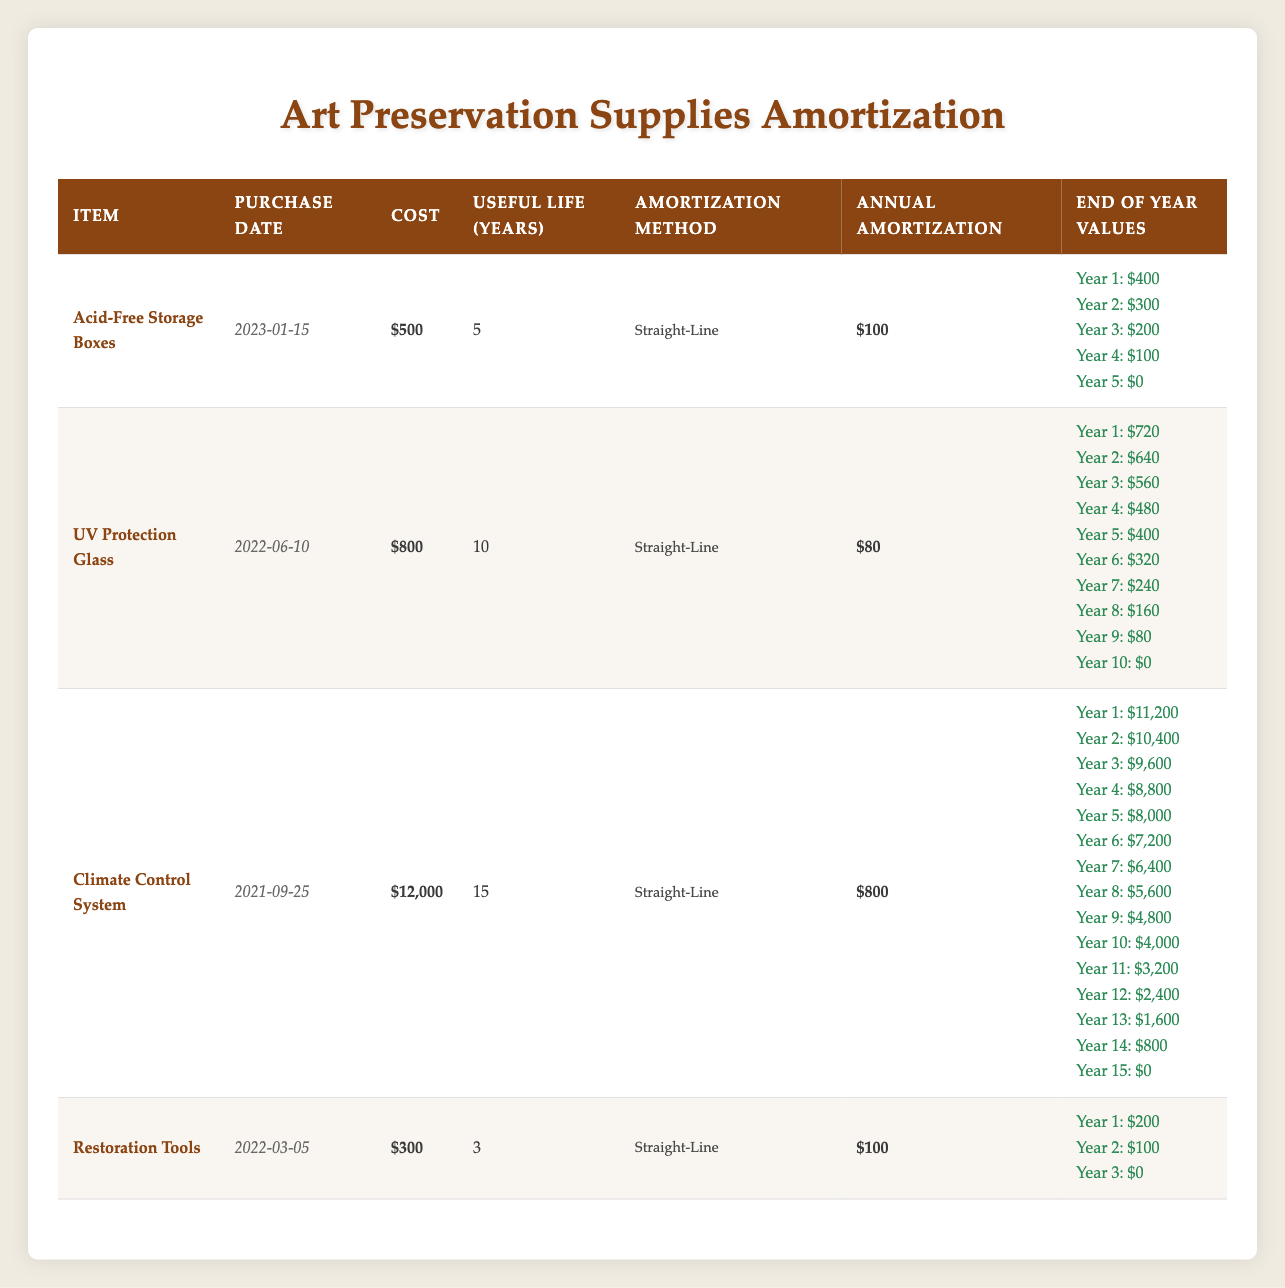What is the annual amortization for the Acid-Free Storage Boxes? The table shows the acid-free storage boxes have an annual amortization of $100 under the "Annual Amortization" column.
Answer: 100 How much is the end-of-year value for the UV Protection Glass at the end of year 5? Looking at the table, the end-of-year value for the UV Protection Glass at year 5 is listed as $400.
Answer: 400 Is the useful life for Restoration Tools greater than 3 years? The table shows that the useful life of the Restoration Tools is exactly 3 years, so the statement is false.
Answer: No What is the total cost of the Climate Control System? The table records the cost of the Climate Control System as $12,000, directly from the "Cost" column.
Answer: 12000 How much will the end-of-year value of the Acid-Free Storage Boxes decrease by the end of year 3 compared to the purchase price? The purchase price is $500, and the end-of-year value at year 3 is $200. The decrease is calculated as $500 - $200 = $300.
Answer: 300 What is the average annual amortization for the items listed in the table? The table lists four items with annual amortizations of $100, $80, $800, and $100. Summing these gives $1080. There are 4 items, so the average is $1080 / 4 = $270.
Answer: 270 Will the Climate Control System be fully amortized by year 10? The Climate Control System has a useful life of 15 years, so it will not be fully amortized by year 10, as it will still have an end-of-year value of $4,000 at that time.
Answer: No What is the difference in annual amortization between the UV Protection Glass and the Climate Control System? The annual amortization for UV Protection Glass is $80 and for the Climate Control System it is $800. The difference is $800 - $80 = $720.
Answer: 720 What is the end-of-year value for the Restoration Tools at year 2? According to the table, the end-of-year value for Restoration Tools at year 2 is identified as $100.
Answer: 100 